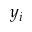<formula> <loc_0><loc_0><loc_500><loc_500>y _ { i }</formula> 